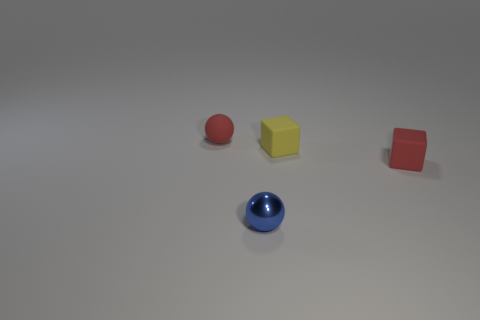Are there any metal balls that have the same size as the shiny thing? Based on the image provided, there appears to be one shiny, metallic ball, and it is unique in both its sheen and material compared to the other objects. Therefore, no other metal balls of the same size are present in the image. 